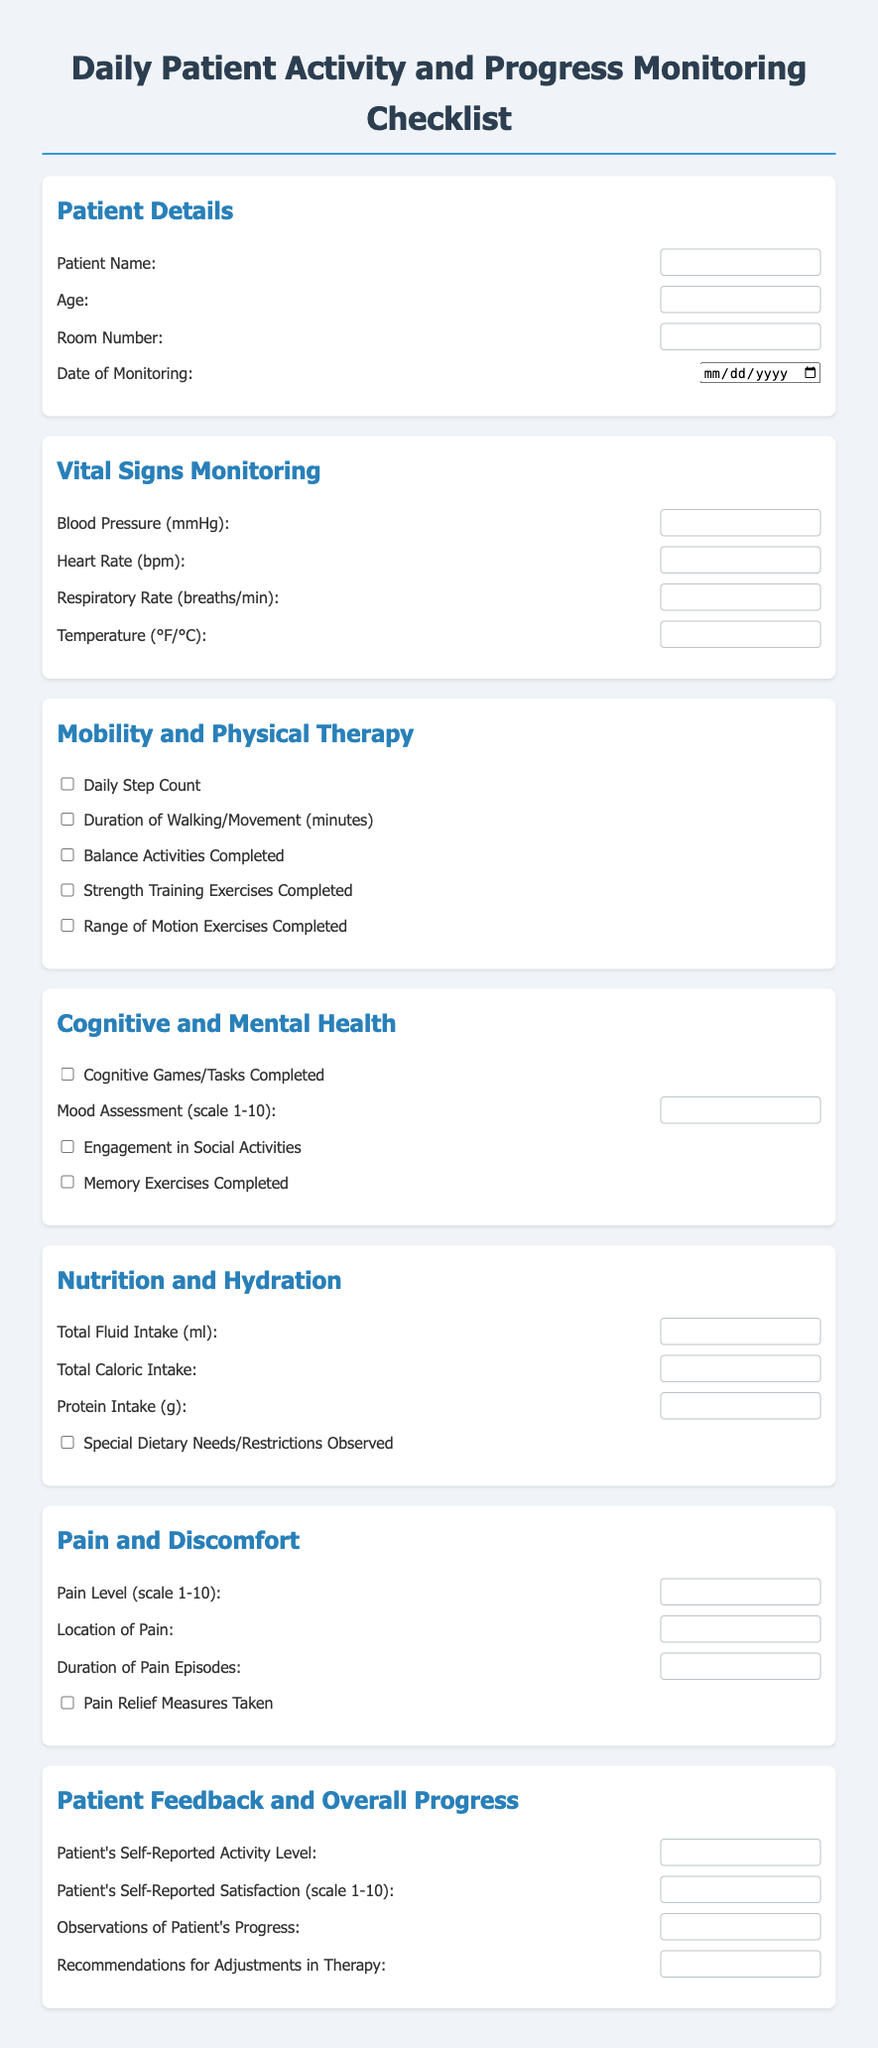what is the patient's name? The patient's name can be filled in at the designated area for Patient Name.
Answer: [Patient Name] what is the age of the patient? The patient's age can be inputted in the specified field for age.
Answer: [Age] how many items are listed under Mobility and Physical Therapy? There are a total of five items related to Mobility and Physical Therapy that the patient must complete.
Answer: 5 what scale is used for the mood assessment? The mood assessment is based on a scale from 1 to 10, where 1 represents the lowest mood and 10 the highest.
Answer: scale 1-10 what should be recorded for fluid intake? The total amount of fluid the patient consumes in milliliters must be recorded in the designated field.
Answer: Total Fluid Intake (ml) how is pain level assessed? The pain level is assessed on a scale from 1 to 10, indicating the severity of pain felt by the patient.
Answer: scale 1-10 what is the purpose of the 'Patient Feedback and Overall Progress' section? This section is intended for capturing the patient's self-reported activity level, satisfaction, progress observations, and therapy recommendations.
Answer: Patient feedback and progress monitoring how many types of dietary considerations are mentioned? There are three dietary considerations outlined in the Nutrition and Hydration section.
Answer: 3 what kind of activities are included under Cognitive and Mental Health? Activities include cognitive games/tasks, mood assessment, social activities, and memory exercises.
Answer: Cognitive games, social activities, memory exercises 